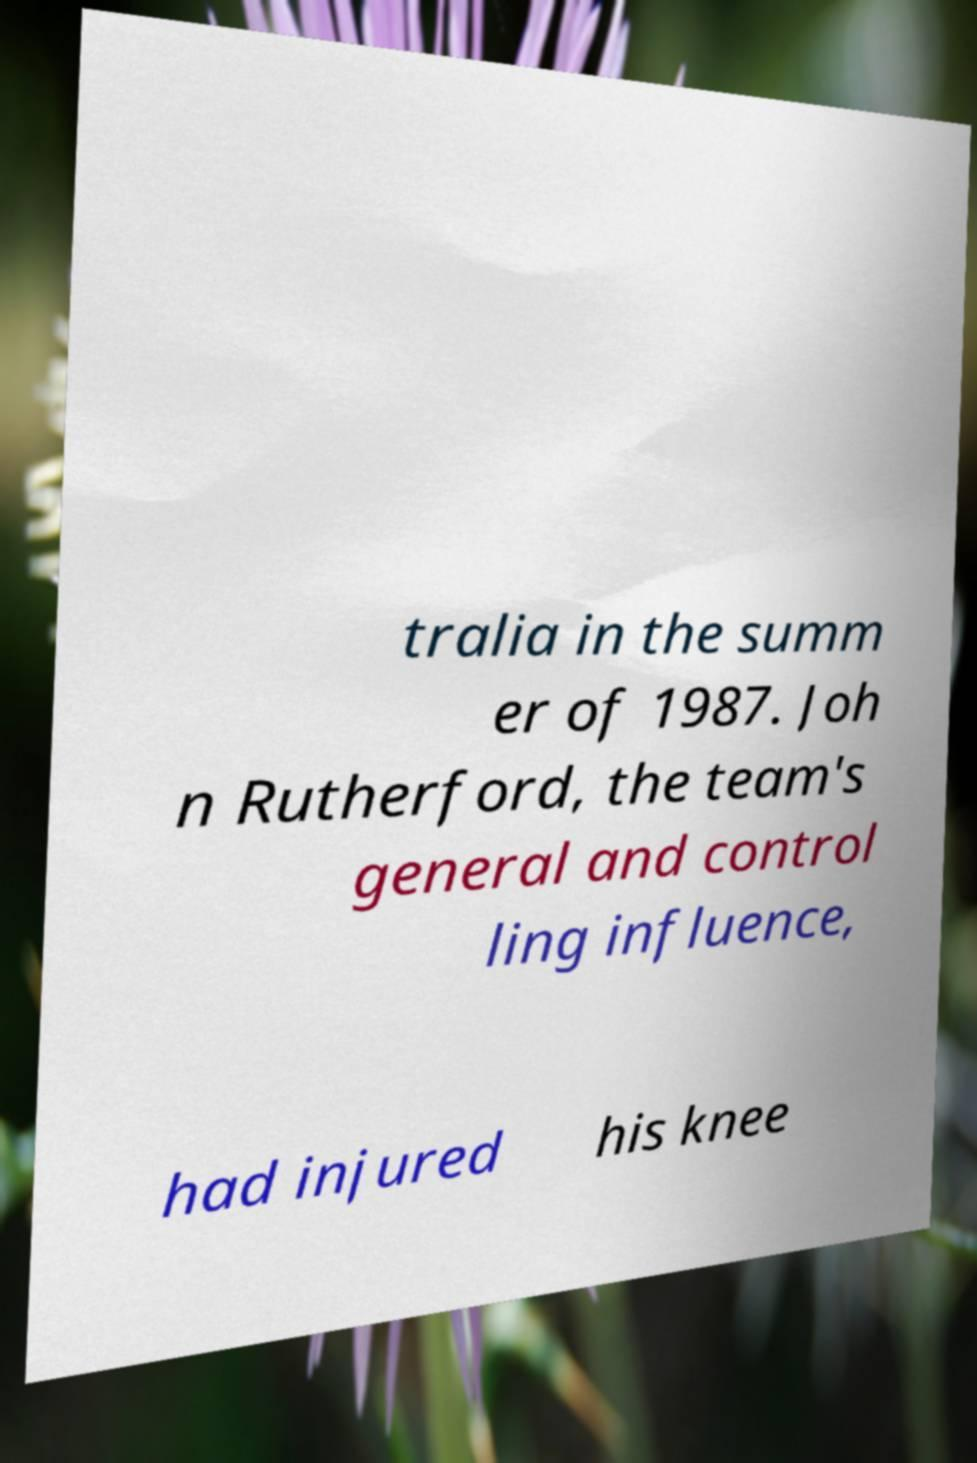I need the written content from this picture converted into text. Can you do that? tralia in the summ er of 1987. Joh n Rutherford, the team's general and control ling influence, had injured his knee 